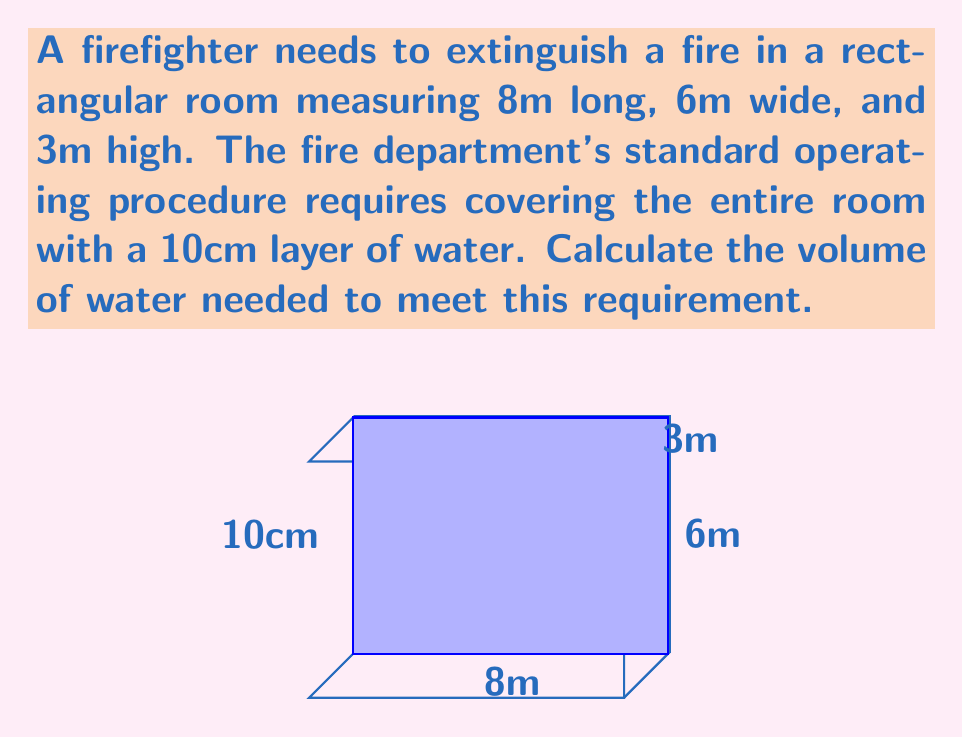Provide a solution to this math problem. To solve this problem, we'll follow these steps:

1) First, we need to calculate the floor area of the room:
   $$ A = l \times w = 8\text{m} \times 6\text{m} = 48\text{m}^2 $$

2) Next, we need to determine the volume of water required. The water layer is 10cm thick, which is 0.1m:
   $$ V = A \times h = 48\text{m}^2 \times 0.1\text{m} = 4.8\text{m}^3 $$

3) Convert cubic meters to liters:
   $$ 1\text{m}^3 = 1000\text{L} $$
   $$ 4.8\text{m}^3 = 4.8 \times 1000 = 4800\text{L} $$

Therefore, the firefighter needs 4800 liters of water to cover the entire room with a 10cm layer of water.
Answer: 4800 L 